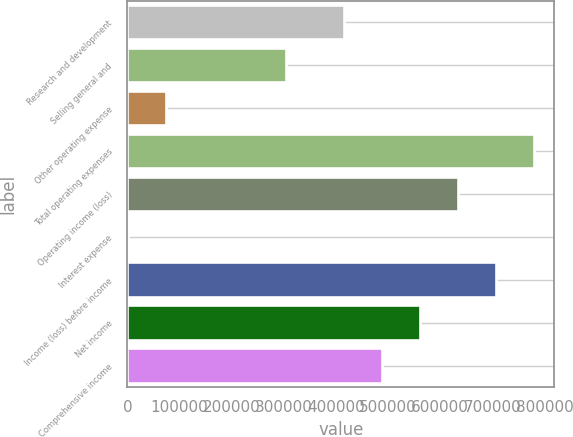Convert chart to OTSL. <chart><loc_0><loc_0><loc_500><loc_500><bar_chart><fcel>Research and development<fcel>Selling general and<fcel>Other operating expense<fcel>Total operating expenses<fcel>Operating income (loss)<fcel>Interest expense<fcel>Income (loss) before income<fcel>Net income<fcel>Comprehensive income<nl><fcel>414571<fcel>305060<fcel>73984<fcel>779636<fcel>633610<fcel>971<fcel>706623<fcel>560597<fcel>487584<nl></chart> 